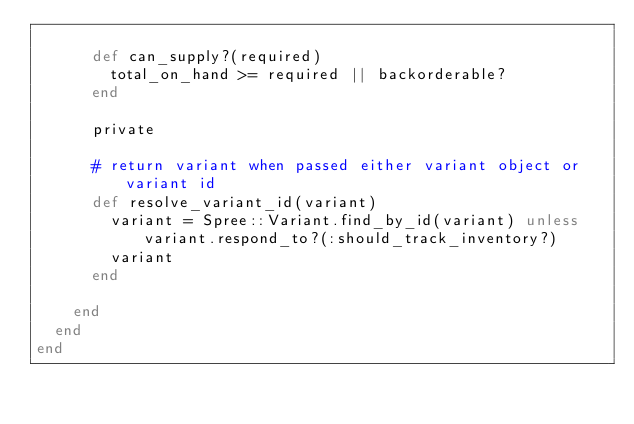Convert code to text. <code><loc_0><loc_0><loc_500><loc_500><_Ruby_>
      def can_supply?(required)
        total_on_hand >= required || backorderable?
      end

      private

      # return variant when passed either variant object or variant id
      def resolve_variant_id(variant)
        variant = Spree::Variant.find_by_id(variant) unless variant.respond_to?(:should_track_inventory?)
        variant
      end

    end
  end
end
</code> 